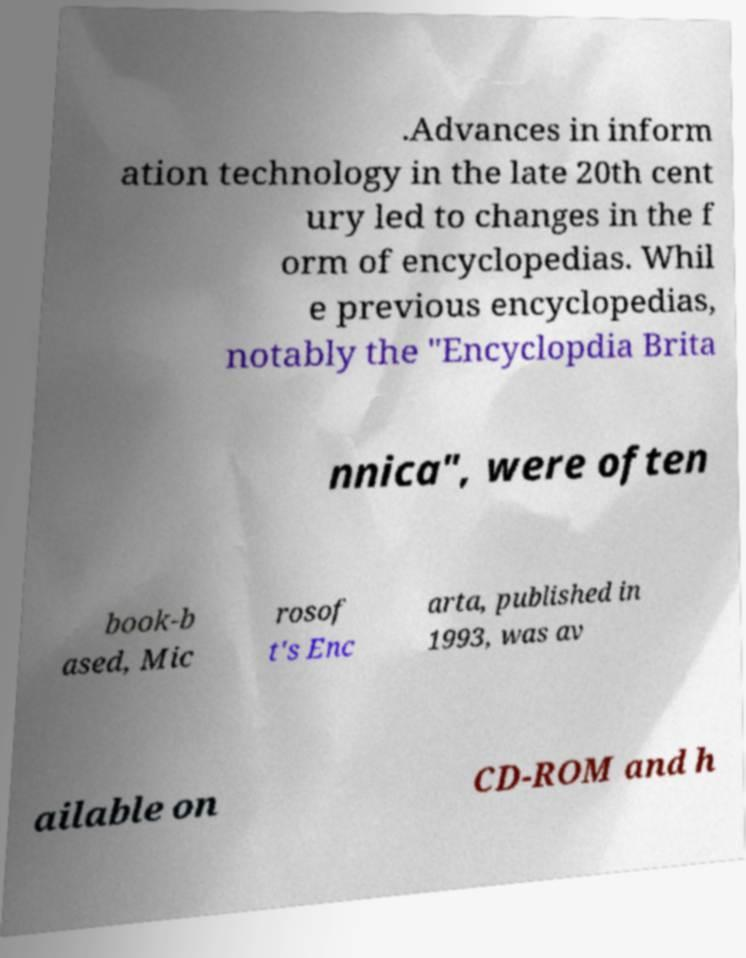Please read and relay the text visible in this image. What does it say? .Advances in inform ation technology in the late 20th cent ury led to changes in the f orm of encyclopedias. Whil e previous encyclopedias, notably the "Encyclopdia Brita nnica", were often book-b ased, Mic rosof t's Enc arta, published in 1993, was av ailable on CD-ROM and h 